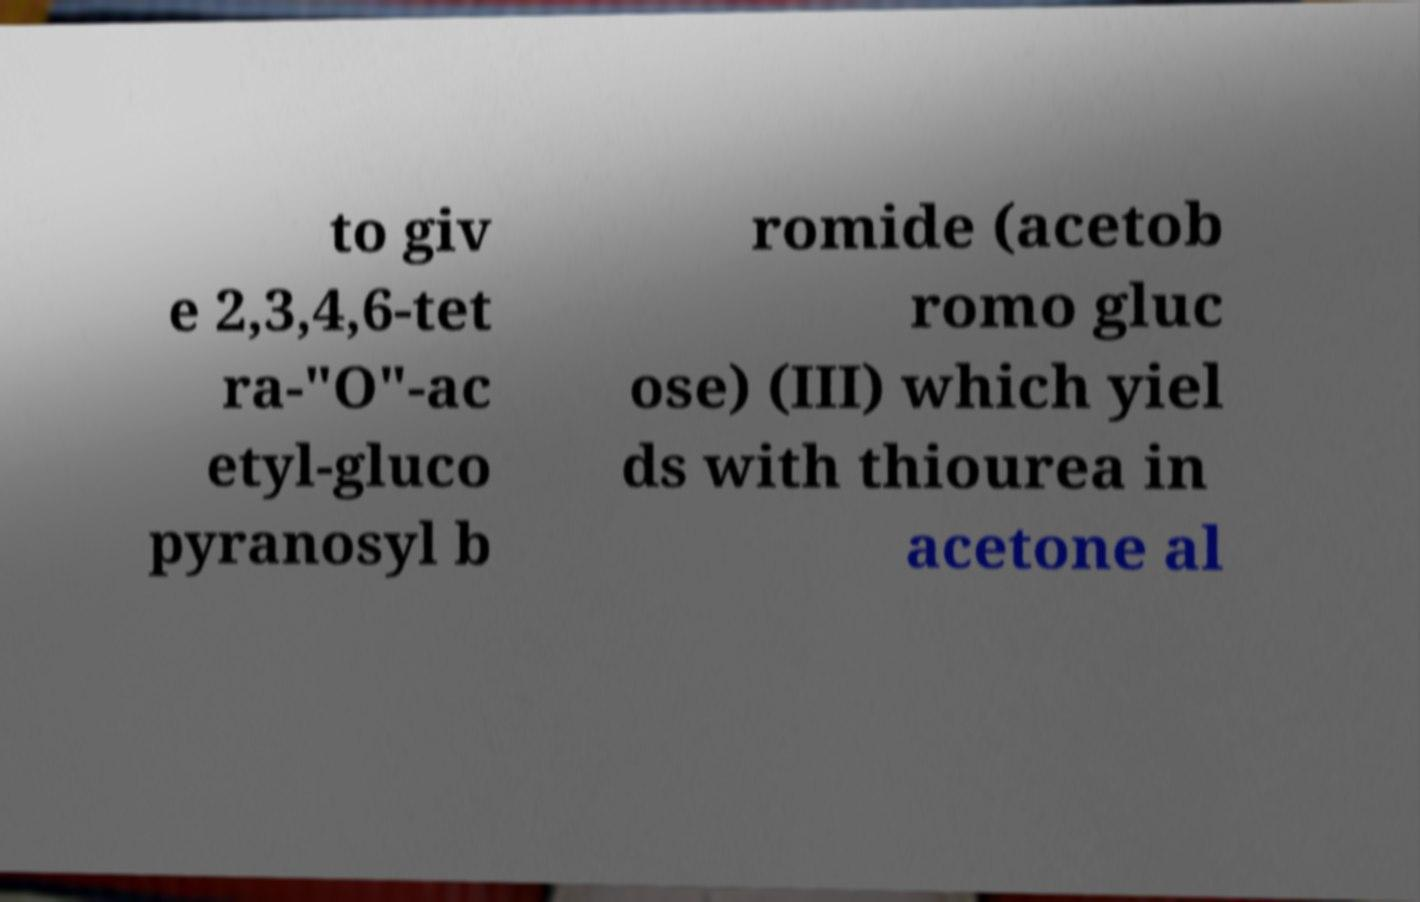Could you extract and type out the text from this image? to giv e 2,3,4,6-tet ra-"O"-ac etyl-gluco pyranosyl b romide (acetob romo gluc ose) (III) which yiel ds with thiourea in acetone al 